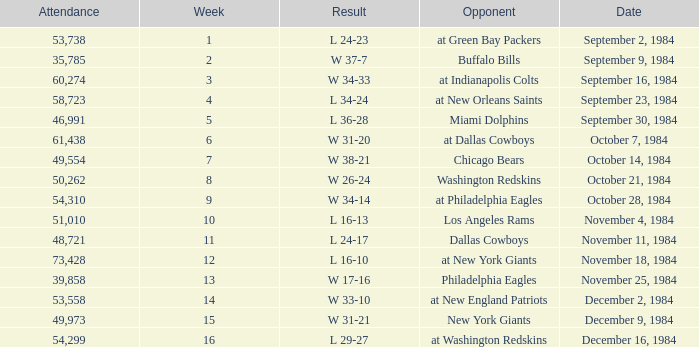Who was the opponent on October 14, 1984? Chicago Bears. 